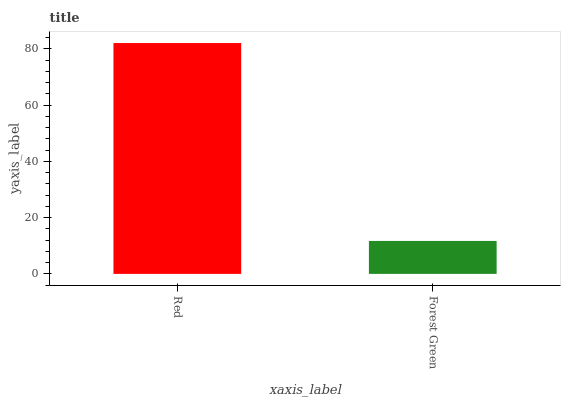Is Forest Green the minimum?
Answer yes or no. Yes. Is Red the maximum?
Answer yes or no. Yes. Is Forest Green the maximum?
Answer yes or no. No. Is Red greater than Forest Green?
Answer yes or no. Yes. Is Forest Green less than Red?
Answer yes or no. Yes. Is Forest Green greater than Red?
Answer yes or no. No. Is Red less than Forest Green?
Answer yes or no. No. Is Red the high median?
Answer yes or no. Yes. Is Forest Green the low median?
Answer yes or no. Yes. Is Forest Green the high median?
Answer yes or no. No. Is Red the low median?
Answer yes or no. No. 